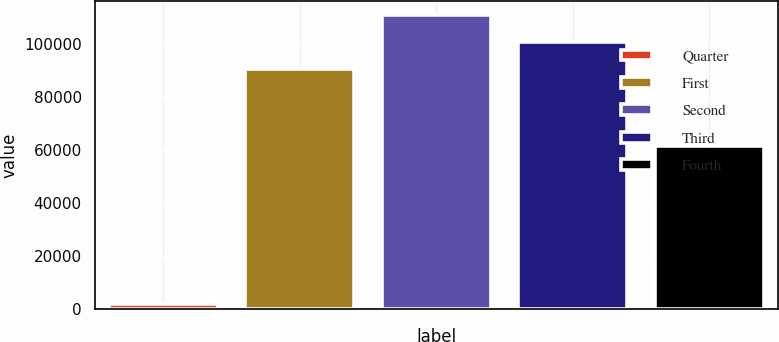Convert chart to OTSL. <chart><loc_0><loc_0><loc_500><loc_500><bar_chart><fcel>Quarter<fcel>First<fcel>Second<fcel>Third<fcel>Fourth<nl><fcel>2013<fcel>90697<fcel>110759<fcel>100728<fcel>61479<nl></chart> 